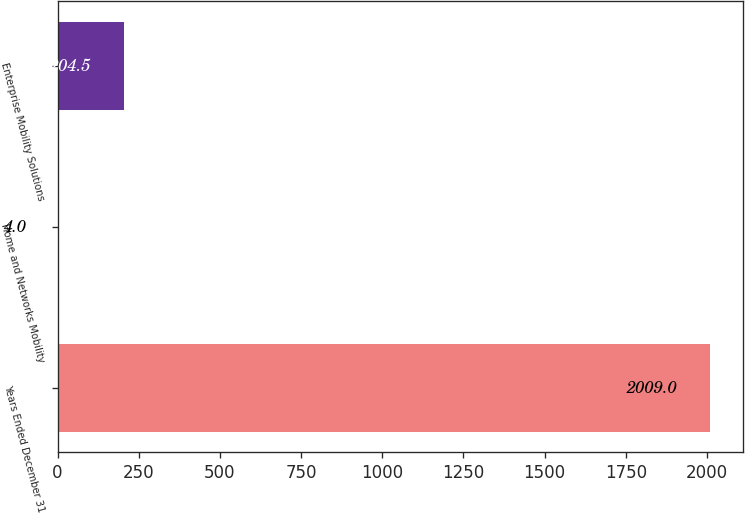Convert chart to OTSL. <chart><loc_0><loc_0><loc_500><loc_500><bar_chart><fcel>Years Ended December 31<fcel>Home and Networks Mobility<fcel>Enterprise Mobility Solutions<nl><fcel>2009<fcel>4<fcel>204.5<nl></chart> 